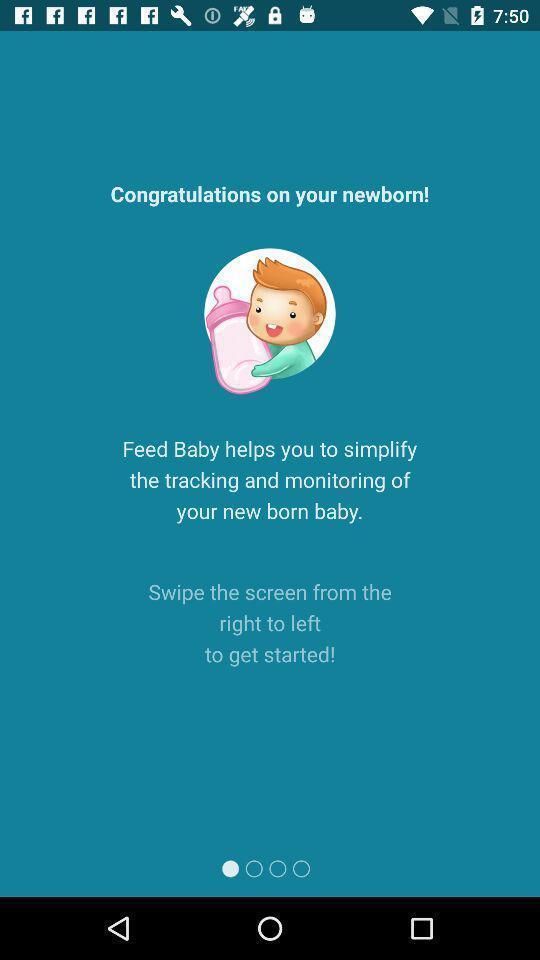Summarize the information in this screenshot. Welcome page of baby tracker app showing message. 